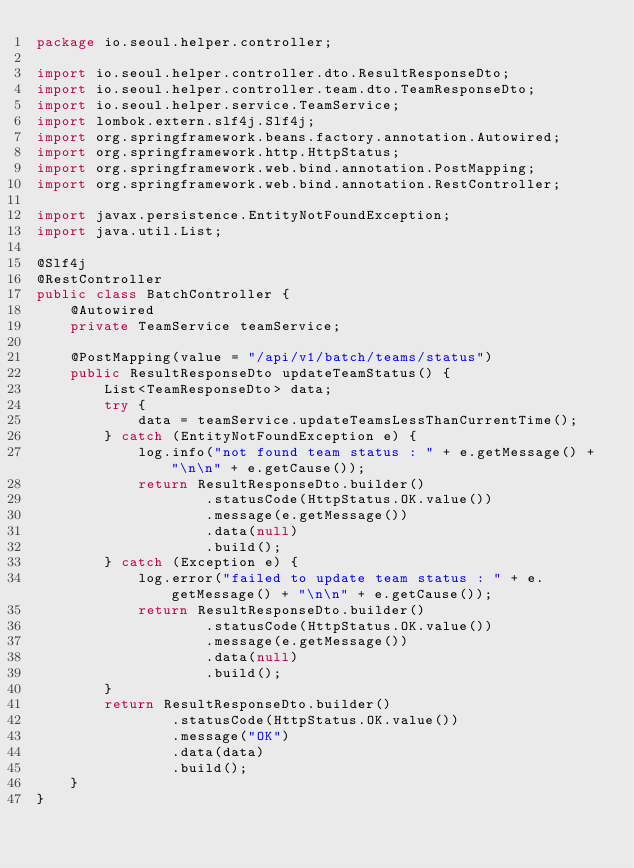<code> <loc_0><loc_0><loc_500><loc_500><_Java_>package io.seoul.helper.controller;

import io.seoul.helper.controller.dto.ResultResponseDto;
import io.seoul.helper.controller.team.dto.TeamResponseDto;
import io.seoul.helper.service.TeamService;
import lombok.extern.slf4j.Slf4j;
import org.springframework.beans.factory.annotation.Autowired;
import org.springframework.http.HttpStatus;
import org.springframework.web.bind.annotation.PostMapping;
import org.springframework.web.bind.annotation.RestController;

import javax.persistence.EntityNotFoundException;
import java.util.List;

@Slf4j
@RestController
public class BatchController {
    @Autowired
    private TeamService teamService;

    @PostMapping(value = "/api/v1/batch/teams/status")
    public ResultResponseDto updateTeamStatus() {
        List<TeamResponseDto> data;
        try {
            data = teamService.updateTeamsLessThanCurrentTime();
        } catch (EntityNotFoundException e) {
            log.info("not found team status : " + e.getMessage() + "\n\n" + e.getCause());
            return ResultResponseDto.builder()
                    .statusCode(HttpStatus.OK.value())
                    .message(e.getMessage())
                    .data(null)
                    .build();
        } catch (Exception e) {
            log.error("failed to update team status : " + e.getMessage() + "\n\n" + e.getCause());
            return ResultResponseDto.builder()
                    .statusCode(HttpStatus.OK.value())
                    .message(e.getMessage())
                    .data(null)
                    .build();
        }
        return ResultResponseDto.builder()
                .statusCode(HttpStatus.OK.value())
                .message("OK")
                .data(data)
                .build();
    }
}
</code> 